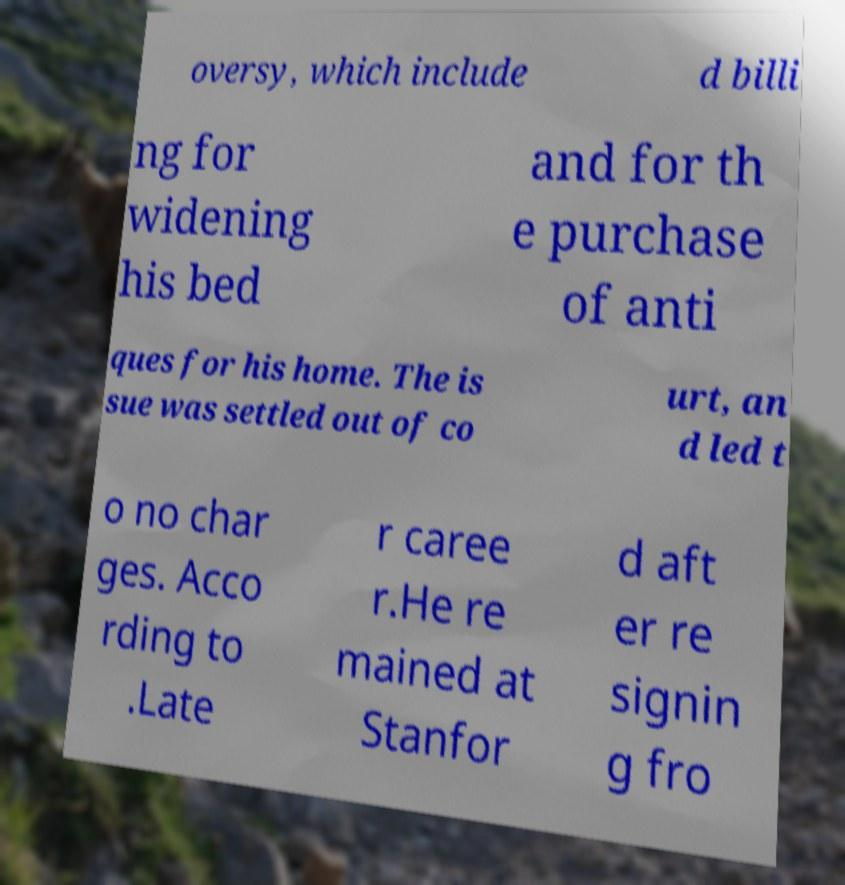Could you extract and type out the text from this image? oversy, which include d billi ng for widening his bed and for th e purchase of anti ques for his home. The is sue was settled out of co urt, an d led t o no char ges. Acco rding to .Late r caree r.He re mained at Stanfor d aft er re signin g fro 